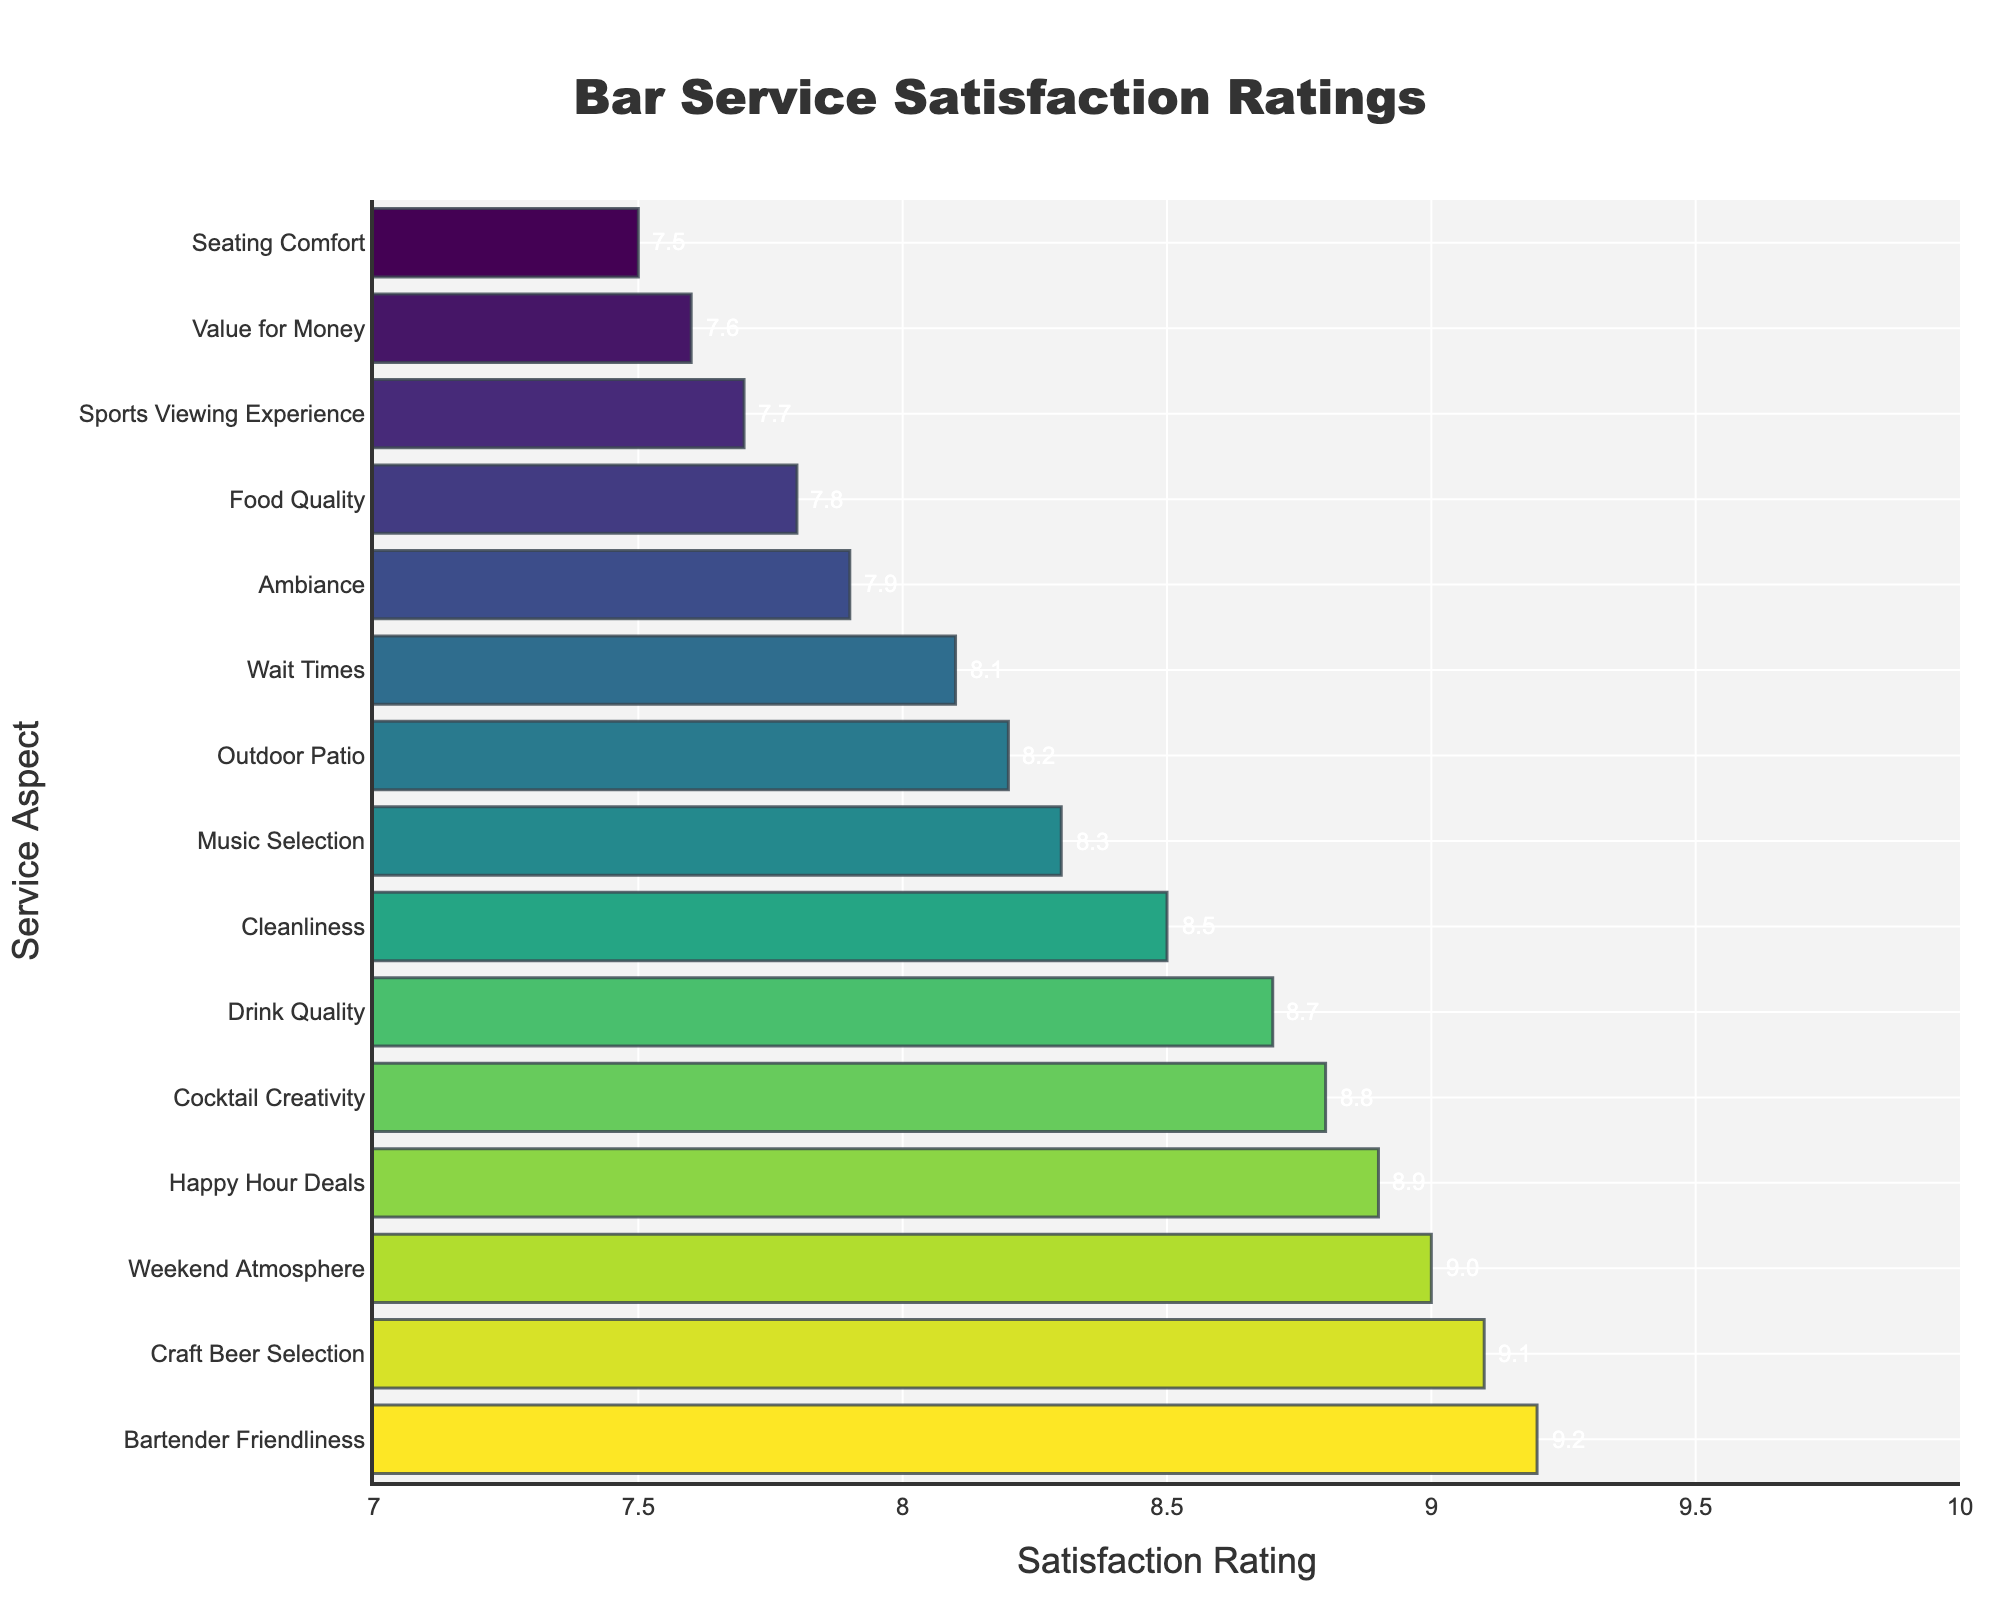Which aspect received the highest satisfaction rating? The highest bar in the chart represents the aspect with the highest satisfaction rating. By looking at the lengths and annotations, "Bartender Friendliness" has the highest rating of 9.2.
Answer: Bartender Friendliness What is the difference in satisfaction ratings between "Craft Beer Selection" and "Value for Money"? The satisfaction rating for "Craft Beer Selection" is 9.1 and for "Value for Money" is 7.6. Subtract 7.6 from 9.1 to get the difference: 9.1 - 7.6.
Answer: 1.5 Which aspect has a satisfaction rating closest to 8.0? By examining the annotations and bar lengths, "Wait Times" has a satisfaction rating of 8.1, which is the closest to 8.0.
Answer: Wait Times How many aspects have a satisfaction rating of 8.5 or higher? Count the aspects with bars annotated as 8.5 or above: "Drink Quality", "Bartender Friendliness", "Cleanliness", "Happy Hour Deals", "Craft Beer Selection", and "Cocktail Creativity".
Answer: 6 Which has a higher satisfaction rating, "Outdoor Patio" or "Music Selection"? Compare the annotated ratings: "Outdoor Patio" has 8.2, and "Music Selection" has 8.3. Therefore, "Music Selection" has a higher rating.
Answer: Music Selection What is the average satisfaction rating for "Ambiance", "Music Selection", and "Cleanliness"? Add the satisfaction ratings for "Ambiance" (7.9), "Music Selection" (8.3), and "Cleanliness" (8.5), then divide by 3 to get the average: (7.9 + 8.3 + 8.5) / 3.
Answer: 8.23 Which aspect has the longest and the shortest bar in the chart? The longest bar represents "Bartender Friendliness" with a satisfaction rating of 9.2, and the shortest bar represents "Seating Comfort" with a satisfaction rating of 7.5.
Answer: Longest: Bartender Friendliness; Shortest: Seating Comfort What is the median satisfaction rating of all aspects? First, list all satisfaction ratings in ascending order: 7.5, 7.6, 7.7, 7.8, 7.9, 8.1, 8.2, 8.3, 8.5, 8.7, 8.8, 8.9, 9.0, 9.1, 9.2. Since there are 15 aspects, the median is the 8th value, which is 8.3.
Answer: 8.3 Is the satisfaction rating of "Happy Hour Deals" greater than the satisfaction rating of "Cocktail Creativity"? Check the ratings from the annotations: "Happy Hour Deals" has 8.9, and "Cocktail Creativity" has 8.8. Thus, yes, the rating for "Happy Hour Deals" is greater.
Answer: Yes 